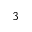<formula> <loc_0><loc_0><loc_500><loc_500>3</formula> 